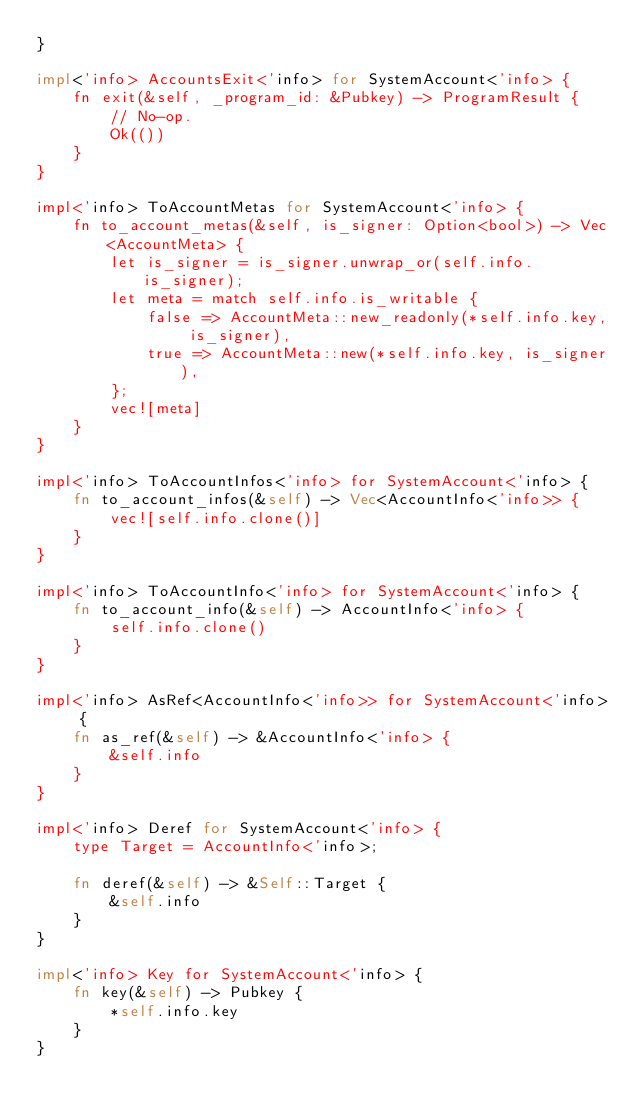<code> <loc_0><loc_0><loc_500><loc_500><_Rust_>}

impl<'info> AccountsExit<'info> for SystemAccount<'info> {
    fn exit(&self, _program_id: &Pubkey) -> ProgramResult {
        // No-op.
        Ok(())
    }
}

impl<'info> ToAccountMetas for SystemAccount<'info> {
    fn to_account_metas(&self, is_signer: Option<bool>) -> Vec<AccountMeta> {
        let is_signer = is_signer.unwrap_or(self.info.is_signer);
        let meta = match self.info.is_writable {
            false => AccountMeta::new_readonly(*self.info.key, is_signer),
            true => AccountMeta::new(*self.info.key, is_signer),
        };
        vec![meta]
    }
}

impl<'info> ToAccountInfos<'info> for SystemAccount<'info> {
    fn to_account_infos(&self) -> Vec<AccountInfo<'info>> {
        vec![self.info.clone()]
    }
}

impl<'info> ToAccountInfo<'info> for SystemAccount<'info> {
    fn to_account_info(&self) -> AccountInfo<'info> {
        self.info.clone()
    }
}

impl<'info> AsRef<AccountInfo<'info>> for SystemAccount<'info> {
    fn as_ref(&self) -> &AccountInfo<'info> {
        &self.info
    }
}

impl<'info> Deref for SystemAccount<'info> {
    type Target = AccountInfo<'info>;

    fn deref(&self) -> &Self::Target {
        &self.info
    }
}

impl<'info> Key for SystemAccount<'info> {
    fn key(&self) -> Pubkey {
        *self.info.key
    }
}
</code> 